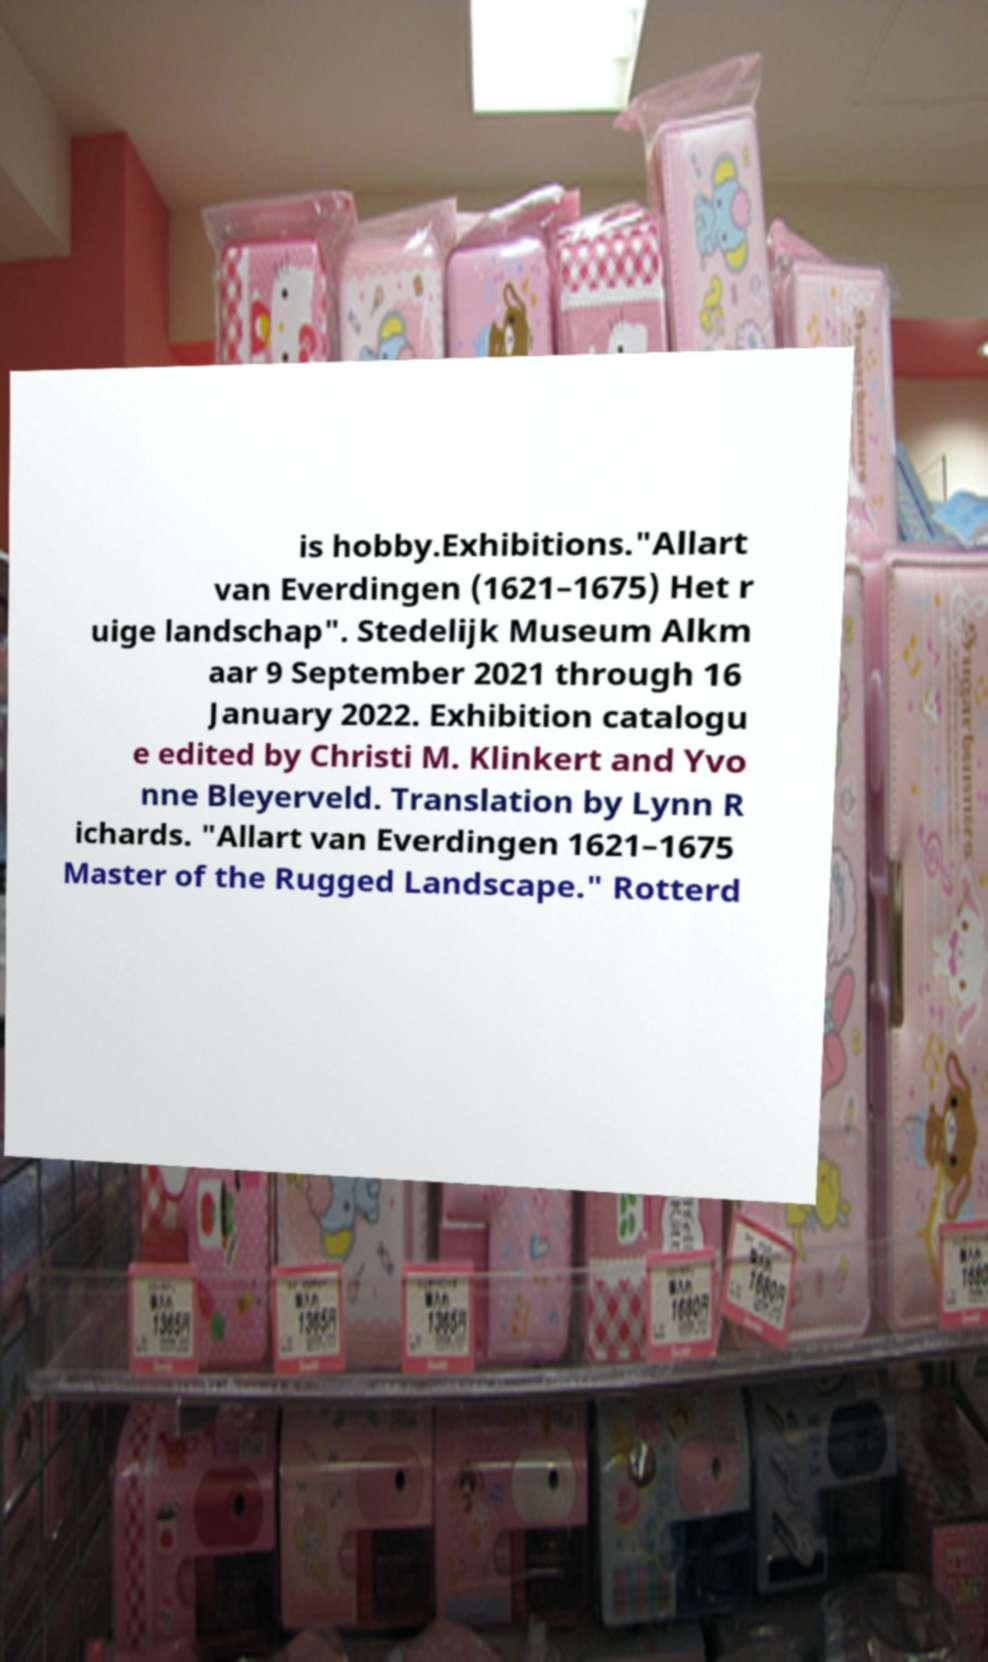There's text embedded in this image that I need extracted. Can you transcribe it verbatim? is hobby.Exhibitions."Allart van Everdingen (1621–1675) Het r uige landschap". Stedelijk Museum Alkm aar 9 September 2021 through 16 January 2022. Exhibition catalogu e edited by Christi M. Klinkert and Yvo nne Bleyerveld. Translation by Lynn R ichards. "Allart van Everdingen 1621–1675 Master of the Rugged Landscape." Rotterd 